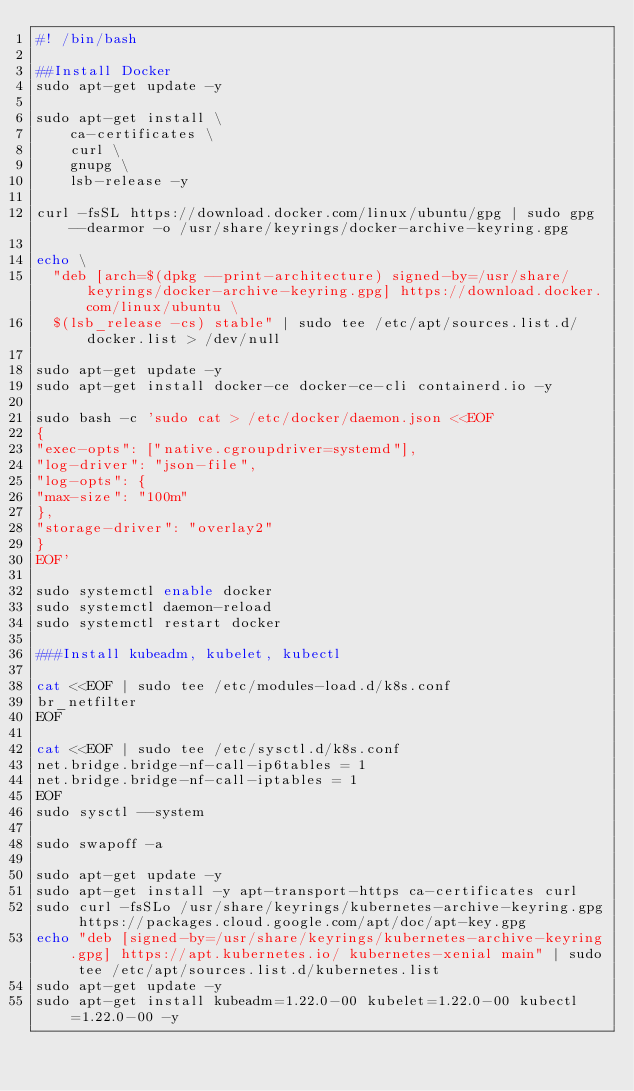<code> <loc_0><loc_0><loc_500><loc_500><_Bash_>#! /bin/bash

##Install Docker
sudo apt-get update -y

sudo apt-get install \
    ca-certificates \
    curl \
    gnupg \
    lsb-release -y

curl -fsSL https://download.docker.com/linux/ubuntu/gpg | sudo gpg --dearmor -o /usr/share/keyrings/docker-archive-keyring.gpg

echo \
  "deb [arch=$(dpkg --print-architecture) signed-by=/usr/share/keyrings/docker-archive-keyring.gpg] https://download.docker.com/linux/ubuntu \
  $(lsb_release -cs) stable" | sudo tee /etc/apt/sources.list.d/docker.list > /dev/null

sudo apt-get update -y
sudo apt-get install docker-ce docker-ce-cli containerd.io -y

sudo bash -c 'sudo cat > /etc/docker/daemon.json <<EOF
{
"exec-opts": ["native.cgroupdriver=systemd"],
"log-driver": "json-file",
"log-opts": {
"max-size": "100m"
},
"storage-driver": "overlay2"
}
EOF'

sudo systemctl enable docker
sudo systemctl daemon-reload
sudo systemctl restart docker

###Install kubeadm, kubelet, kubectl

cat <<EOF | sudo tee /etc/modules-load.d/k8s.conf
br_netfilter
EOF

cat <<EOF | sudo tee /etc/sysctl.d/k8s.conf
net.bridge.bridge-nf-call-ip6tables = 1
net.bridge.bridge-nf-call-iptables = 1
EOF
sudo sysctl --system

sudo swapoff -a

sudo apt-get update -y
sudo apt-get install -y apt-transport-https ca-certificates curl
sudo curl -fsSLo /usr/share/keyrings/kubernetes-archive-keyring.gpg https://packages.cloud.google.com/apt/doc/apt-key.gpg
echo "deb [signed-by=/usr/share/keyrings/kubernetes-archive-keyring.gpg] https://apt.kubernetes.io/ kubernetes-xenial main" | sudo tee /etc/apt/sources.list.d/kubernetes.list
sudo apt-get update -y
sudo apt-get install kubeadm=1.22.0-00 kubelet=1.22.0-00 kubectl=1.22.0-00 -y
</code> 